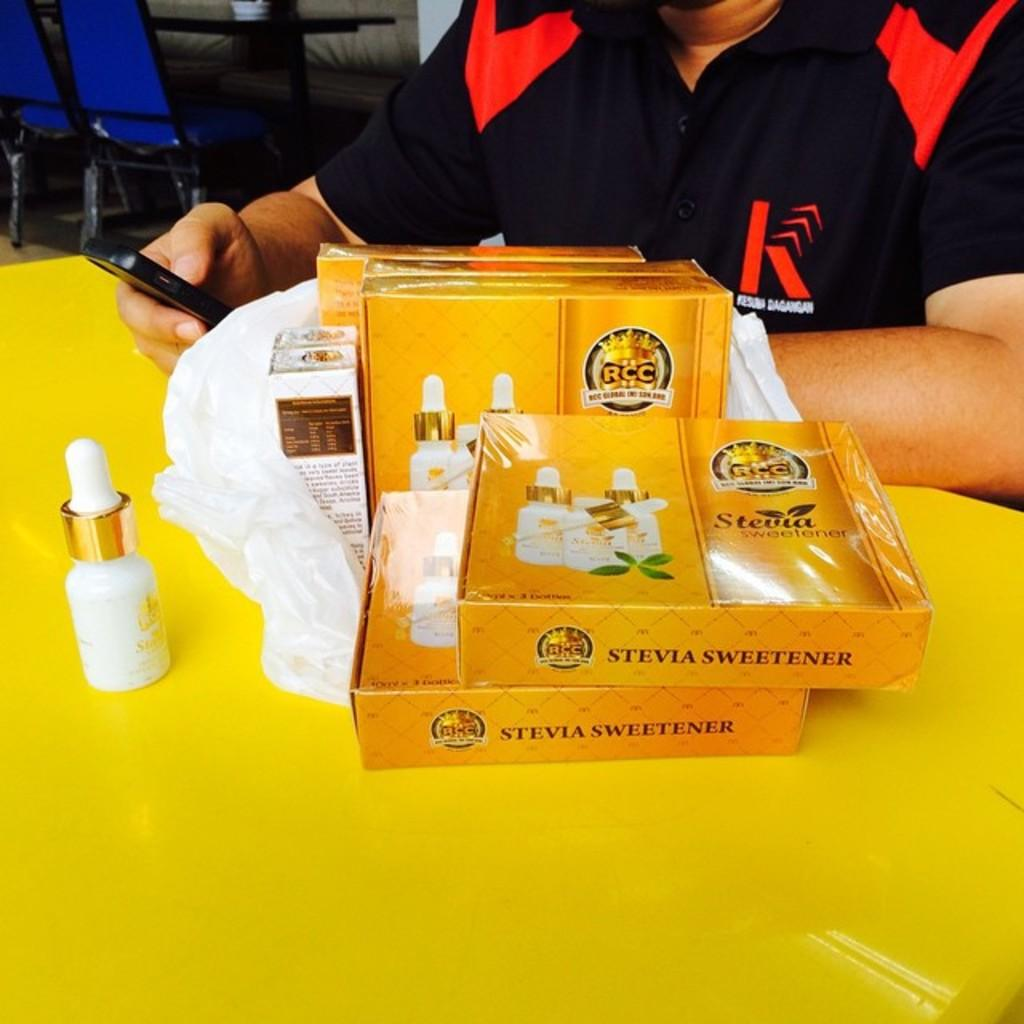<image>
Offer a succinct explanation of the picture presented. Packages of Stevia Sweetners and a person holding a smartphone at a table. 